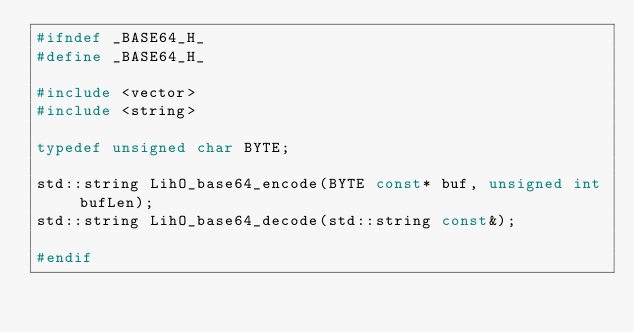<code> <loc_0><loc_0><loc_500><loc_500><_C_>#ifndef _BASE64_H_
#define _BASE64_H_

#include <vector>
#include <string>

typedef unsigned char BYTE;

std::string LihO_base64_encode(BYTE const* buf, unsigned int bufLen);
std::string LihO_base64_decode(std::string const&);

#endif
</code> 